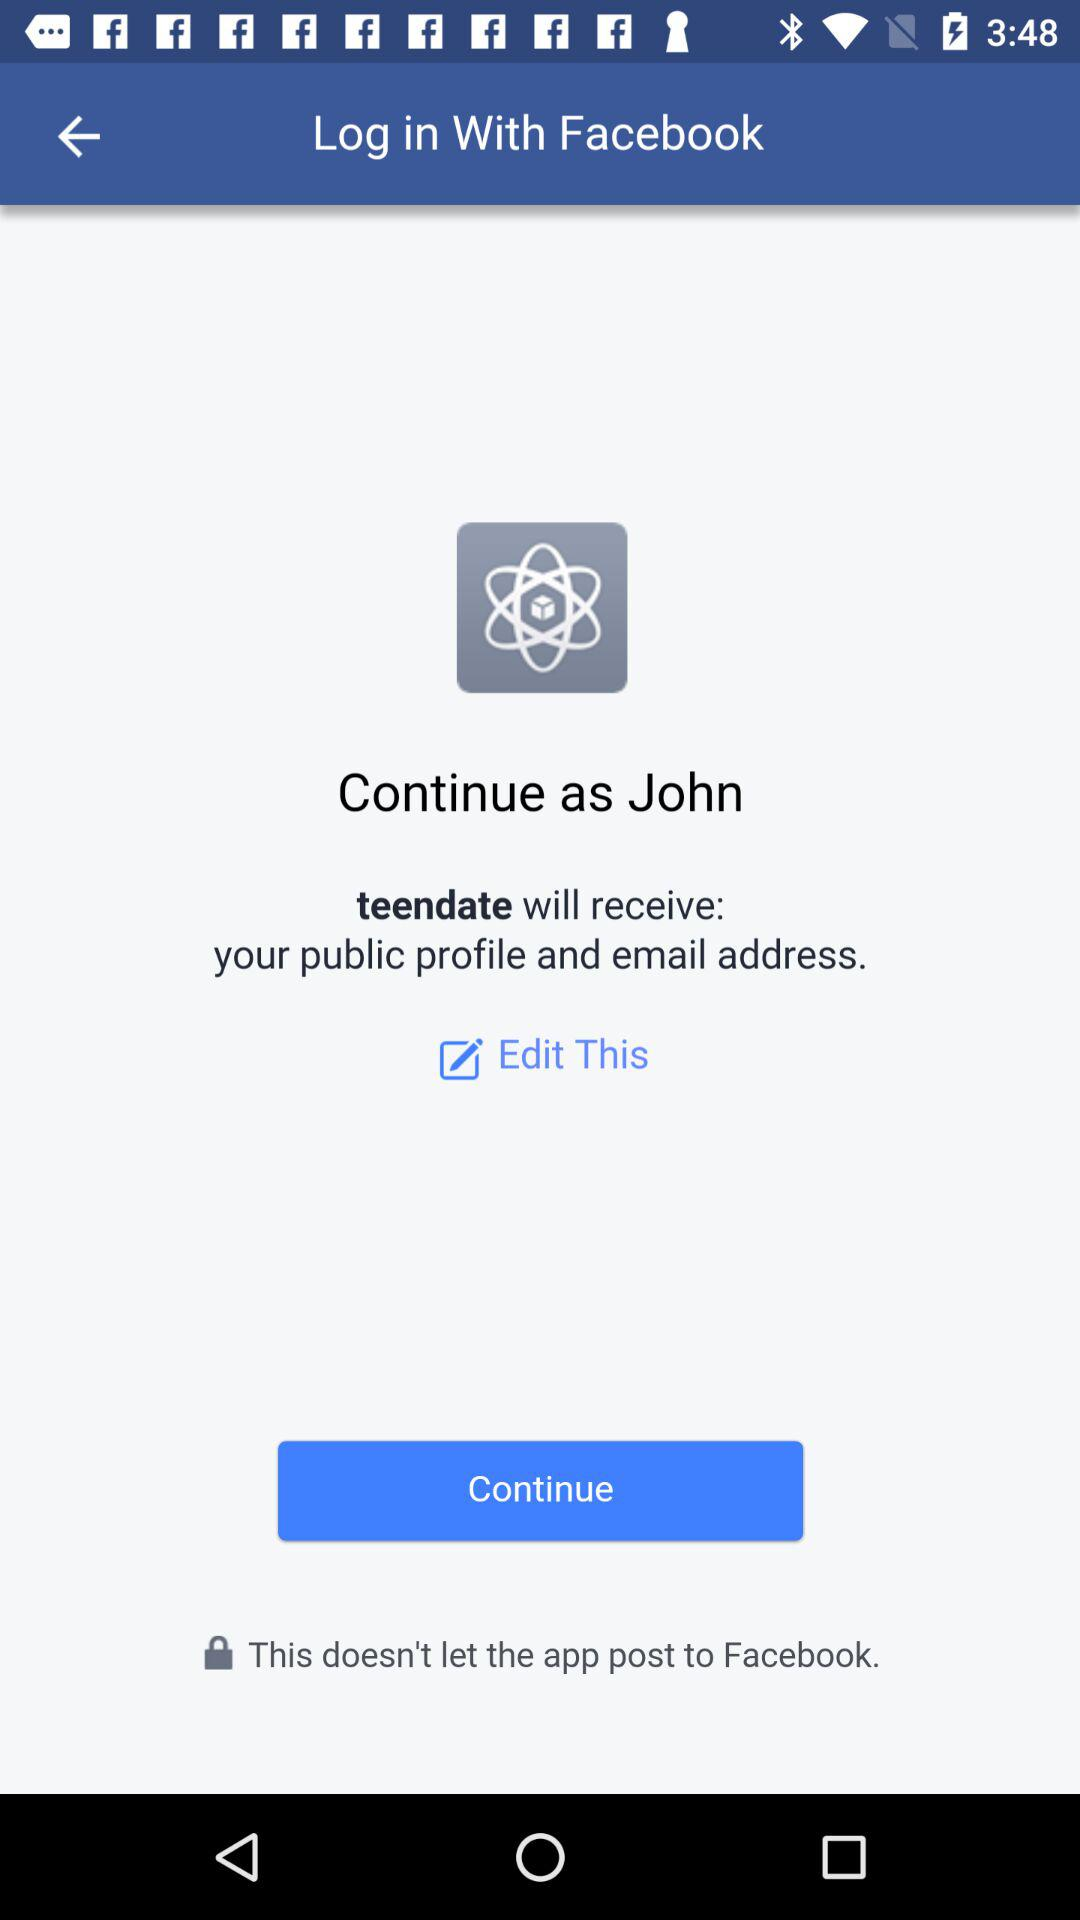What is the name of the user? The name of the user is John. 